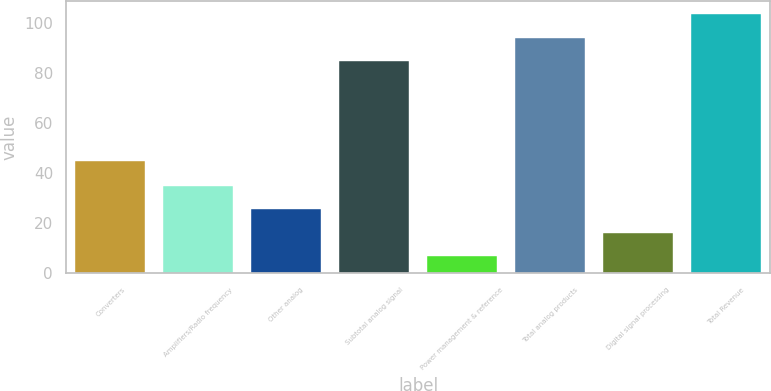Convert chart to OTSL. <chart><loc_0><loc_0><loc_500><loc_500><bar_chart><fcel>Converters<fcel>Amplifiers/Radio frequency<fcel>Other analog<fcel>Subtotal analog signal<fcel>Power management & reference<fcel>Total analog products<fcel>Digital signal processing<fcel>Total Revenue<nl><fcel>45<fcel>34.9<fcel>25.6<fcel>85<fcel>7<fcel>94.3<fcel>16.3<fcel>103.6<nl></chart> 